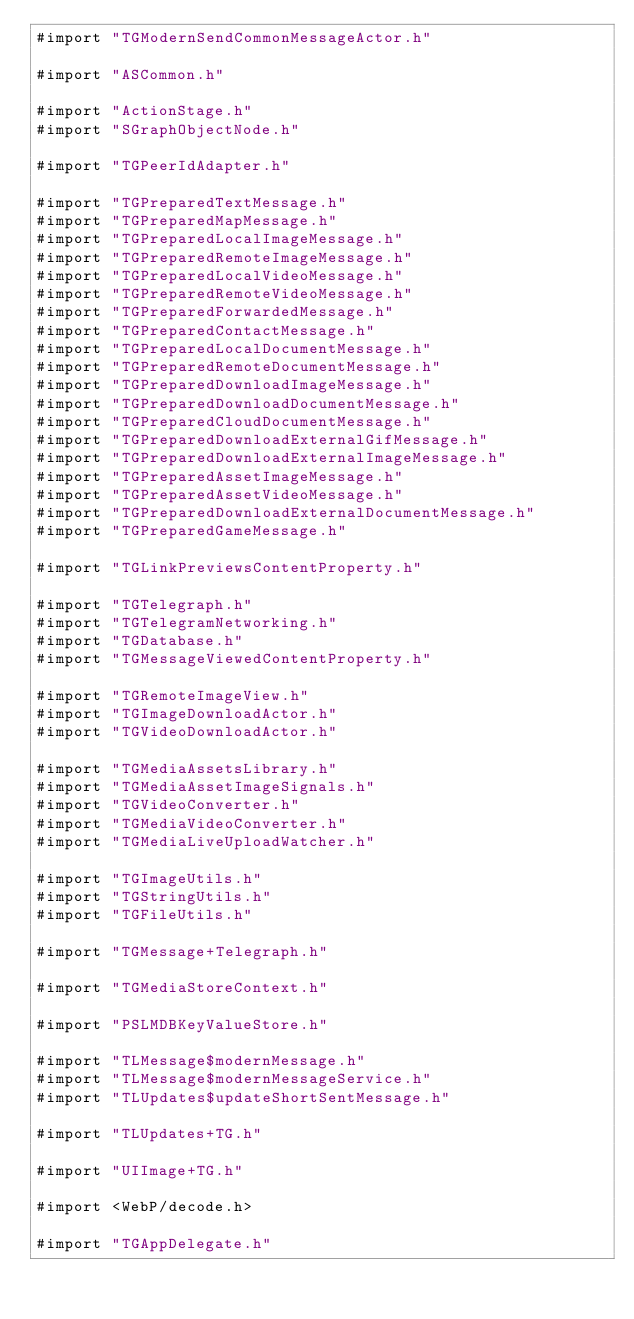Convert code to text. <code><loc_0><loc_0><loc_500><loc_500><_ObjectiveC_>#import "TGModernSendCommonMessageActor.h"

#import "ASCommon.h"

#import "ActionStage.h"
#import "SGraphObjectNode.h"

#import "TGPeerIdAdapter.h"

#import "TGPreparedTextMessage.h"
#import "TGPreparedMapMessage.h"
#import "TGPreparedLocalImageMessage.h"
#import "TGPreparedRemoteImageMessage.h"
#import "TGPreparedLocalVideoMessage.h"
#import "TGPreparedRemoteVideoMessage.h"
#import "TGPreparedForwardedMessage.h"
#import "TGPreparedContactMessage.h"
#import "TGPreparedLocalDocumentMessage.h"
#import "TGPreparedRemoteDocumentMessage.h"
#import "TGPreparedDownloadImageMessage.h"
#import "TGPreparedDownloadDocumentMessage.h"
#import "TGPreparedCloudDocumentMessage.h"
#import "TGPreparedDownloadExternalGifMessage.h"
#import "TGPreparedDownloadExternalImageMessage.h"
#import "TGPreparedAssetImageMessage.h"
#import "TGPreparedAssetVideoMessage.h"
#import "TGPreparedDownloadExternalDocumentMessage.h"
#import "TGPreparedGameMessage.h"

#import "TGLinkPreviewsContentProperty.h"

#import "TGTelegraph.h"
#import "TGTelegramNetworking.h"
#import "TGDatabase.h"
#import "TGMessageViewedContentProperty.h"

#import "TGRemoteImageView.h"
#import "TGImageDownloadActor.h"
#import "TGVideoDownloadActor.h"

#import "TGMediaAssetsLibrary.h"
#import "TGMediaAssetImageSignals.h"
#import "TGVideoConverter.h"
#import "TGMediaVideoConverter.h"
#import "TGMediaLiveUploadWatcher.h"

#import "TGImageUtils.h"
#import "TGStringUtils.h"
#import "TGFileUtils.h"

#import "TGMessage+Telegraph.h"

#import "TGMediaStoreContext.h"

#import "PSLMDBKeyValueStore.h"

#import "TLMessage$modernMessage.h"
#import "TLMessage$modernMessageService.h"
#import "TLUpdates$updateShortSentMessage.h"

#import "TLUpdates+TG.h"

#import "UIImage+TG.h"

#import <WebP/decode.h>

#import "TGAppDelegate.h"
</code> 